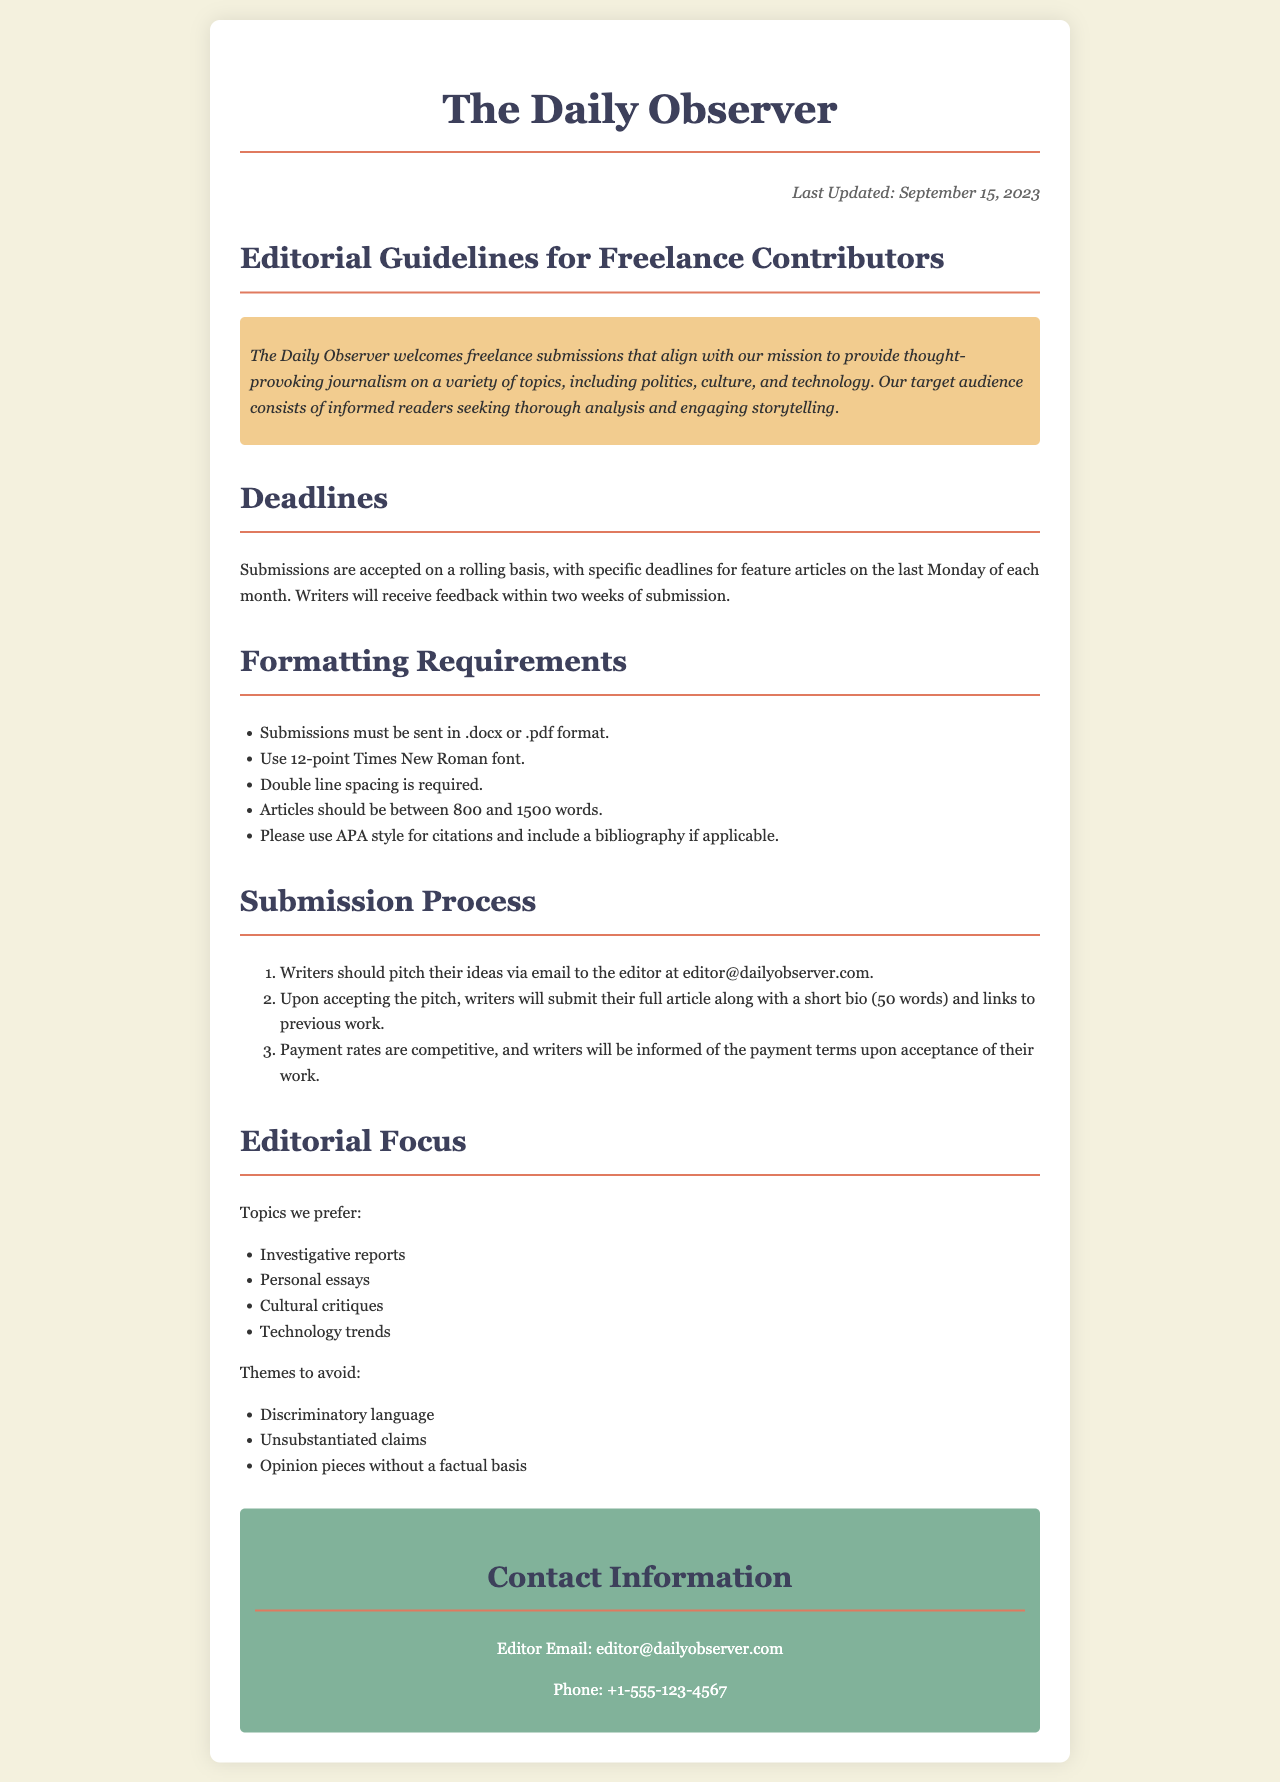What is the last updated date? The last updated date is found in the document's header, indicating when the guidelines were revised.
Answer: September 15, 2023 What format should submissions be sent in? Submissions must be sent in specific formats, mentioned in the formatting requirements section.
Answer: .docx or .pdf How long do writers have to wait for feedback after submission? This information is stated in the deadlines section regarding the feedback timeline.
Answer: Two weeks What font size is required for submissions? The font size requirement is detailed under the formatting section of the document.
Answer: 12-point What types of essays are preferred by The Daily Observer? This question asks about specific topics listed under the editorial focus of the document.
Answer: Personal essays How often are feature article deadlines? The frequency of feature article deadlines is explained in the deadlines section of the document.
Answer: Monthly What specific themes should be avoided in submissions? The document specifies certain themes to avoid under the editorial focus section, which guides contributors.
Answer: Discriminatory language Who should writers pitch their ideas to? This information is found in the submission process outlining the pitching procedure for writers.
Answer: Editor What is the email address for the editor? This contact information is explicitly provided in the contact information section at the end of the document.
Answer: editor@dailyobserver.com 